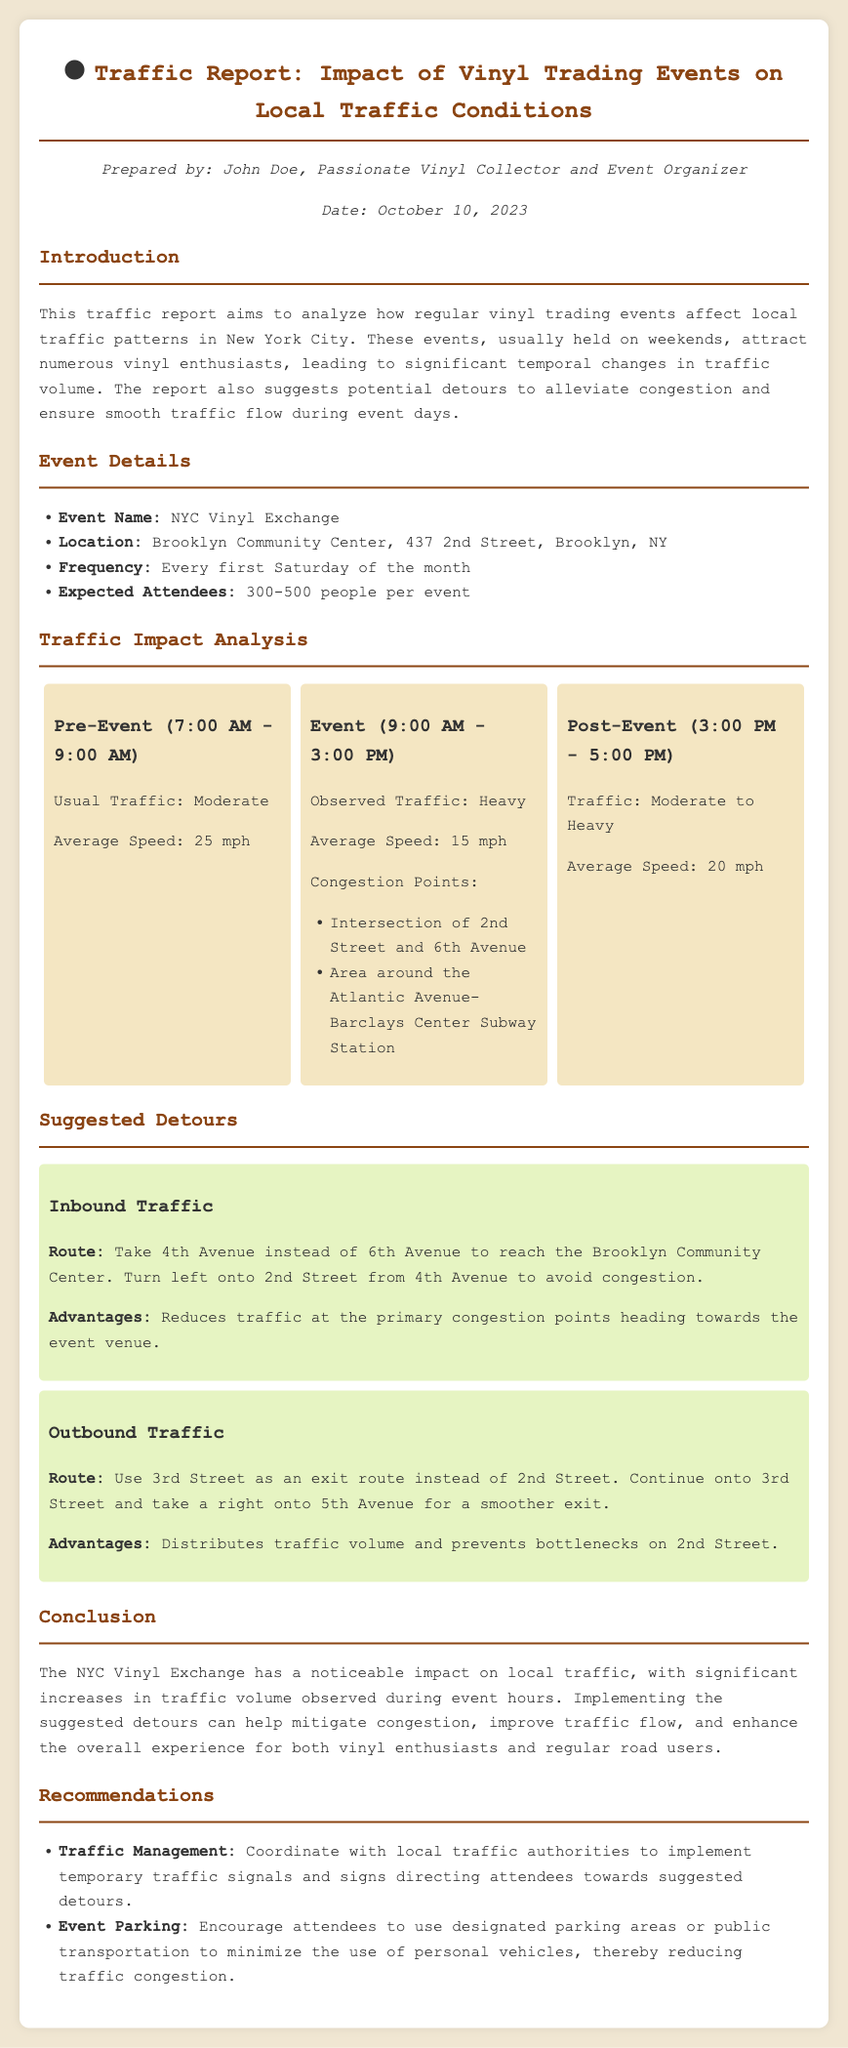what is the name of the event? The event is referred to as "NYC Vinyl Exchange" in the document.
Answer: NYC Vinyl Exchange what is the location of the event? The document specifies that the event takes place at "Brooklyn Community Center, 437 2nd Street, Brooklyn, NY."
Answer: Brooklyn Community Center, 437 2nd Street, Brooklyn, NY how many expected attendees are there? The report states that the expected number of attendees ranges from 300 to 500 people.
Answer: 300-500 what is the average speed during the event? The observed average speed during the event hours is presented as 15 mph in the report.
Answer: 15 mph which intersection is a congestion point? The document lists the "Intersection of 2nd Street and 6th Avenue" as one of the congestion points.
Answer: Intersection of 2nd Street and 6th Avenue what is the suggested route for inbound traffic? The report advises taking "4th Avenue instead of 6th Avenue" as the suggested route for inbound traffic.
Answer: 4th Avenue instead of 6th Avenue what are the advantages of the suggested outbound traffic route? The document mentions that the outbound route "distributes traffic volume and prevents bottlenecks on 2nd Street."
Answer: Distributes traffic volume and prevents bottlenecks on 2nd Street what is the significance of the traffic volume during the event? The report indicates that the NYC Vinyl Exchange has a "noticeable impact on local traffic" with significant increases during event hours.
Answer: Noticeable impact on local traffic what recommendations does the document give regarding event parking? It suggests encouraging attendees to use "designated parking areas or public transportation" to minimize personal vehicle use.
Answer: Designated parking areas or public transportation 